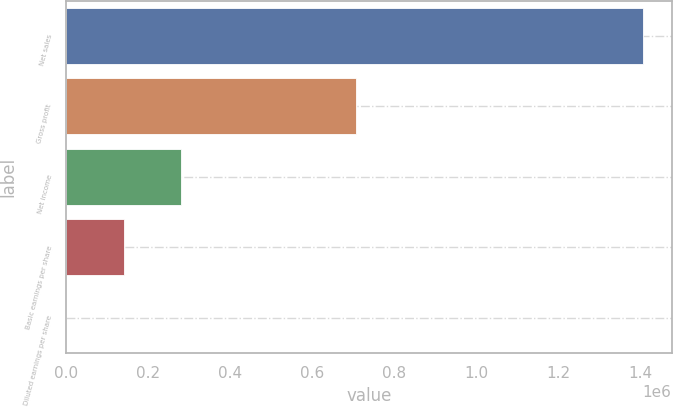<chart> <loc_0><loc_0><loc_500><loc_500><bar_chart><fcel>Net sales<fcel>Gross profit<fcel>Net income<fcel>Basic earnings per share<fcel>Diluted earnings per share<nl><fcel>1.40651e+06<fcel>707785<fcel>281303<fcel>140652<fcel>1.03<nl></chart> 